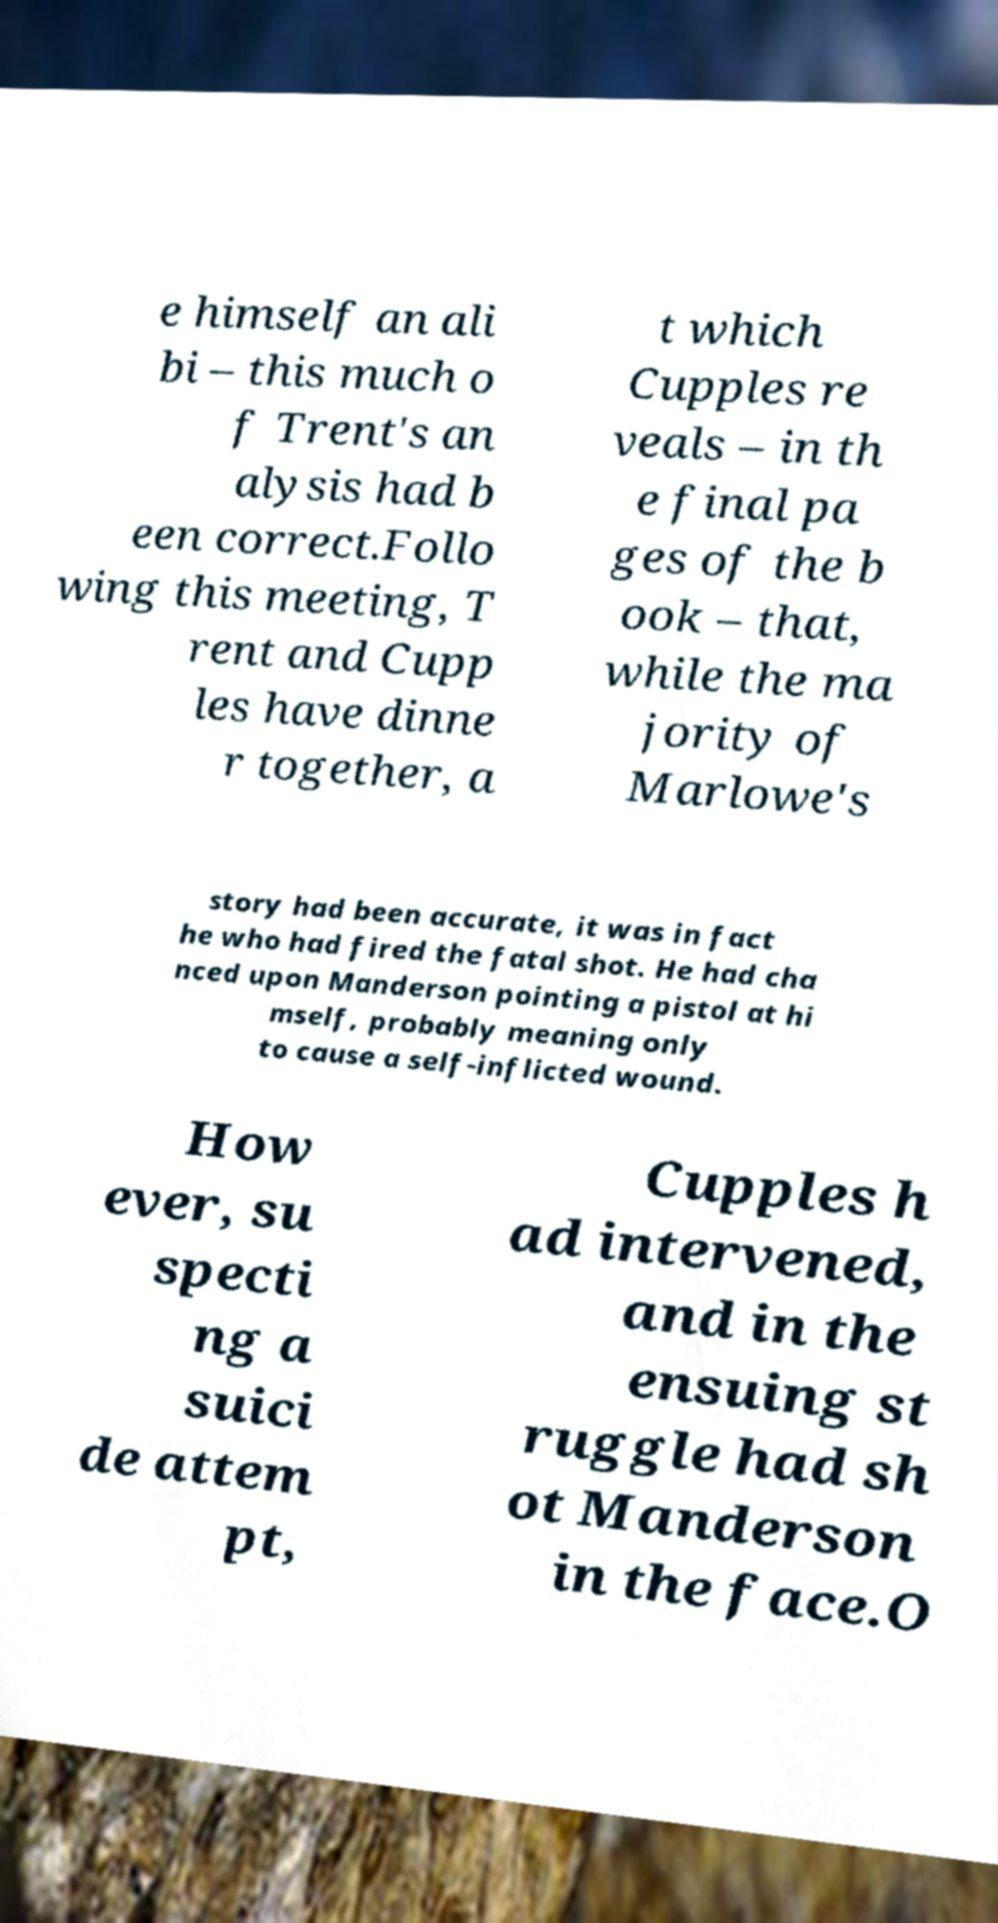There's text embedded in this image that I need extracted. Can you transcribe it verbatim? e himself an ali bi – this much o f Trent's an alysis had b een correct.Follo wing this meeting, T rent and Cupp les have dinne r together, a t which Cupples re veals – in th e final pa ges of the b ook – that, while the ma jority of Marlowe's story had been accurate, it was in fact he who had fired the fatal shot. He had cha nced upon Manderson pointing a pistol at hi mself, probably meaning only to cause a self-inflicted wound. How ever, su specti ng a suici de attem pt, Cupples h ad intervened, and in the ensuing st ruggle had sh ot Manderson in the face.O 